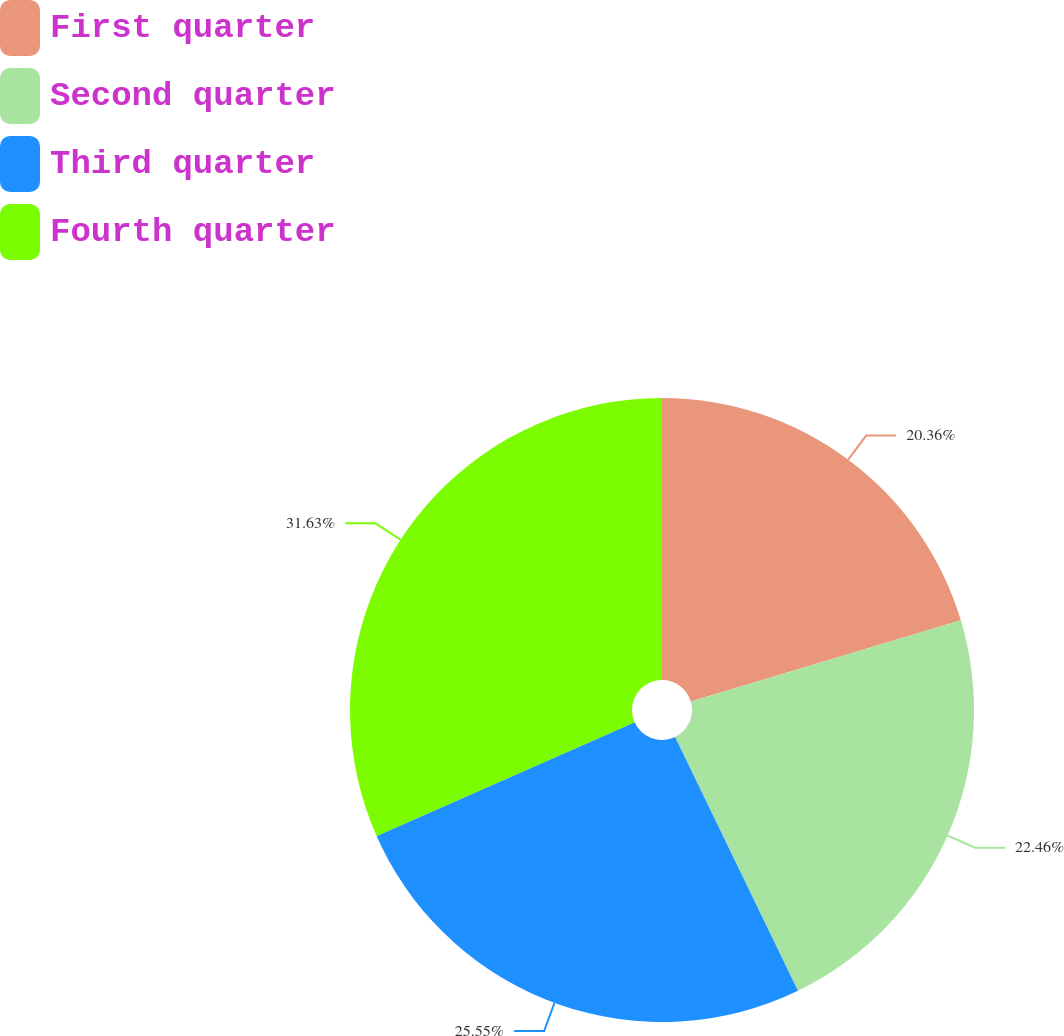<chart> <loc_0><loc_0><loc_500><loc_500><pie_chart><fcel>First quarter<fcel>Second quarter<fcel>Third quarter<fcel>Fourth quarter<nl><fcel>20.36%<fcel>22.46%<fcel>25.55%<fcel>31.62%<nl></chart> 